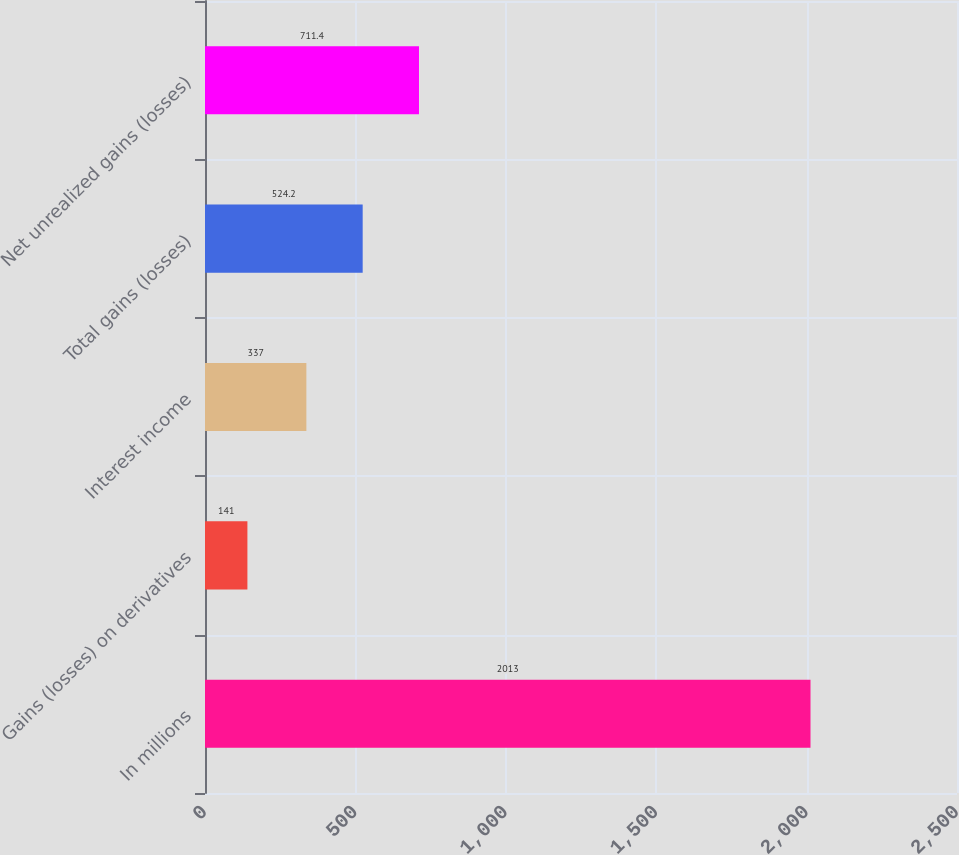Convert chart. <chart><loc_0><loc_0><loc_500><loc_500><bar_chart><fcel>In millions<fcel>Gains (losses) on derivatives<fcel>Interest income<fcel>Total gains (losses)<fcel>Net unrealized gains (losses)<nl><fcel>2013<fcel>141<fcel>337<fcel>524.2<fcel>711.4<nl></chart> 